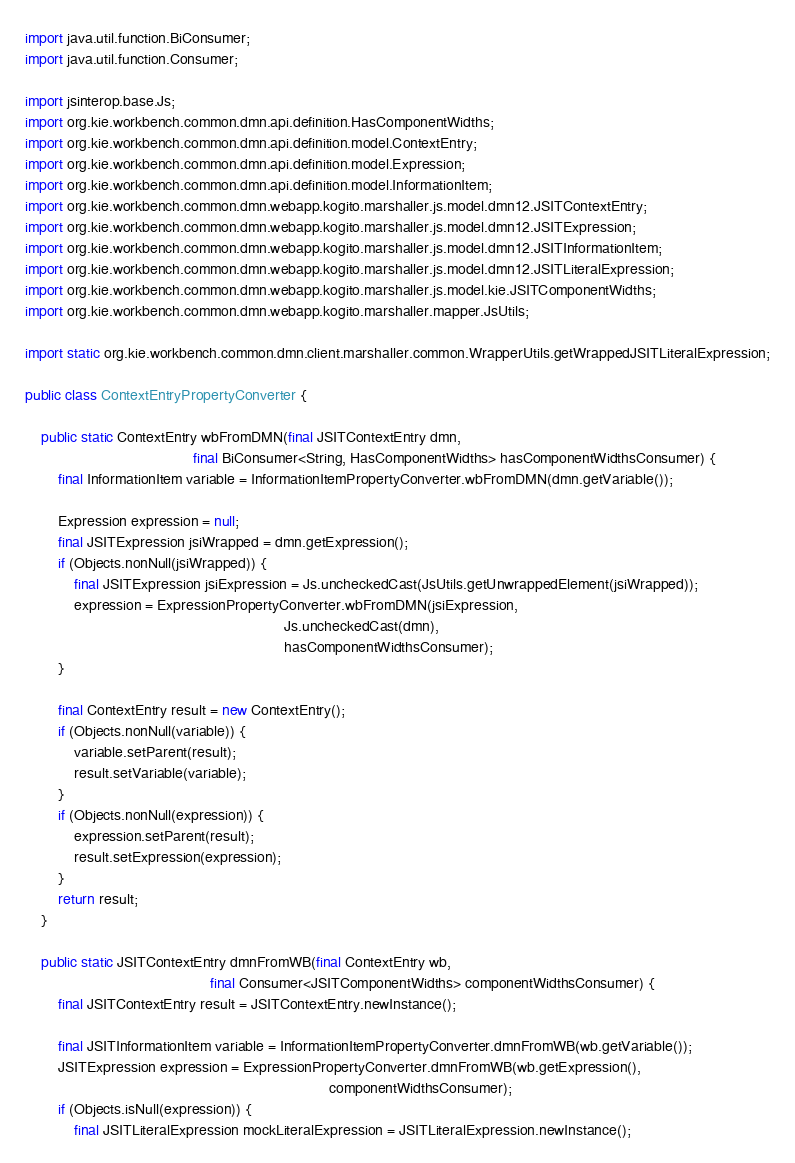<code> <loc_0><loc_0><loc_500><loc_500><_Java_>import java.util.function.BiConsumer;
import java.util.function.Consumer;

import jsinterop.base.Js;
import org.kie.workbench.common.dmn.api.definition.HasComponentWidths;
import org.kie.workbench.common.dmn.api.definition.model.ContextEntry;
import org.kie.workbench.common.dmn.api.definition.model.Expression;
import org.kie.workbench.common.dmn.api.definition.model.InformationItem;
import org.kie.workbench.common.dmn.webapp.kogito.marshaller.js.model.dmn12.JSITContextEntry;
import org.kie.workbench.common.dmn.webapp.kogito.marshaller.js.model.dmn12.JSITExpression;
import org.kie.workbench.common.dmn.webapp.kogito.marshaller.js.model.dmn12.JSITInformationItem;
import org.kie.workbench.common.dmn.webapp.kogito.marshaller.js.model.dmn12.JSITLiteralExpression;
import org.kie.workbench.common.dmn.webapp.kogito.marshaller.js.model.kie.JSITComponentWidths;
import org.kie.workbench.common.dmn.webapp.kogito.marshaller.mapper.JsUtils;

import static org.kie.workbench.common.dmn.client.marshaller.common.WrapperUtils.getWrappedJSITLiteralExpression;

public class ContextEntryPropertyConverter {

    public static ContextEntry wbFromDMN(final JSITContextEntry dmn,
                                         final BiConsumer<String, HasComponentWidths> hasComponentWidthsConsumer) {
        final InformationItem variable = InformationItemPropertyConverter.wbFromDMN(dmn.getVariable());

        Expression expression = null;
        final JSITExpression jsiWrapped = dmn.getExpression();
        if (Objects.nonNull(jsiWrapped)) {
            final JSITExpression jsiExpression = Js.uncheckedCast(JsUtils.getUnwrappedElement(jsiWrapped));
            expression = ExpressionPropertyConverter.wbFromDMN(jsiExpression,
                                                               Js.uncheckedCast(dmn),
                                                               hasComponentWidthsConsumer);
        }

        final ContextEntry result = new ContextEntry();
        if (Objects.nonNull(variable)) {
            variable.setParent(result);
            result.setVariable(variable);
        }
        if (Objects.nonNull(expression)) {
            expression.setParent(result);
            result.setExpression(expression);
        }
        return result;
    }

    public static JSITContextEntry dmnFromWB(final ContextEntry wb,
                                             final Consumer<JSITComponentWidths> componentWidthsConsumer) {
        final JSITContextEntry result = JSITContextEntry.newInstance();

        final JSITInformationItem variable = InformationItemPropertyConverter.dmnFromWB(wb.getVariable());
        JSITExpression expression = ExpressionPropertyConverter.dmnFromWB(wb.getExpression(),
                                                                          componentWidthsConsumer);
        if (Objects.isNull(expression)) {
            final JSITLiteralExpression mockLiteralExpression = JSITLiteralExpression.newInstance();</code> 